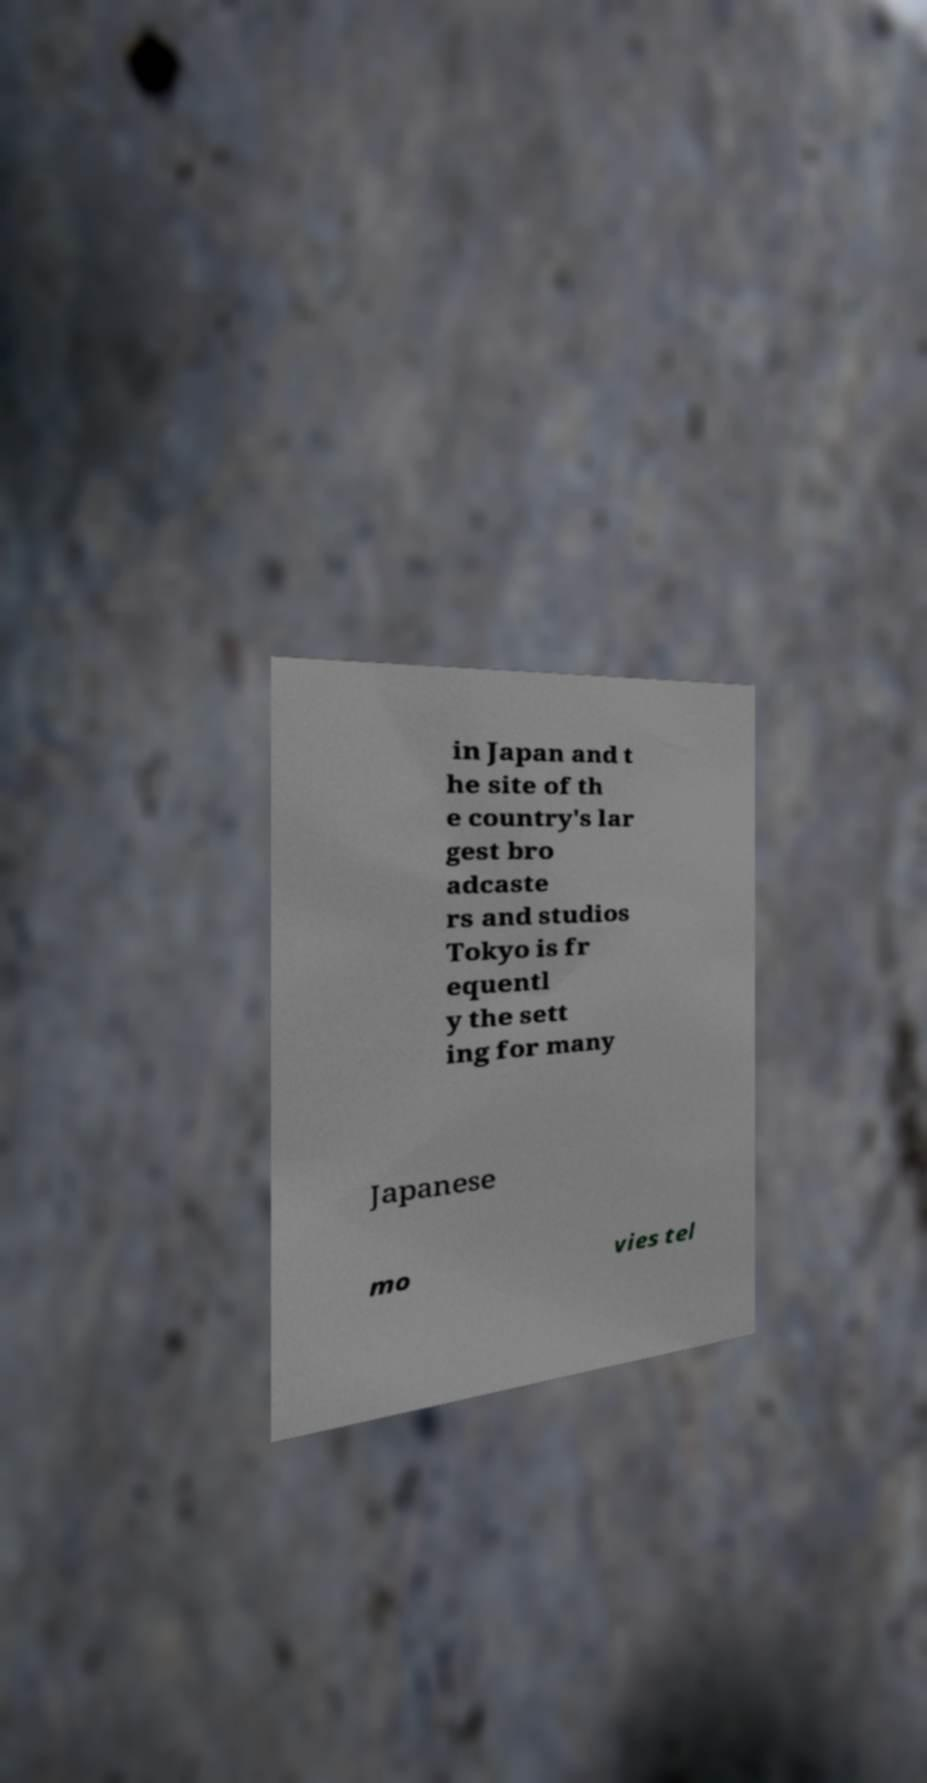I need the written content from this picture converted into text. Can you do that? in Japan and t he site of th e country's lar gest bro adcaste rs and studios Tokyo is fr equentl y the sett ing for many Japanese mo vies tel 